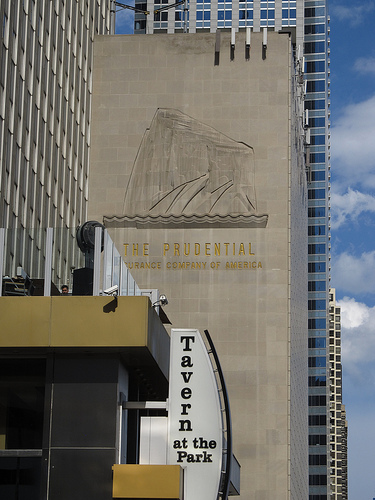<image>
Can you confirm if the sign is on the building? Yes. Looking at the image, I can see the sign is positioned on top of the building, with the building providing support. 